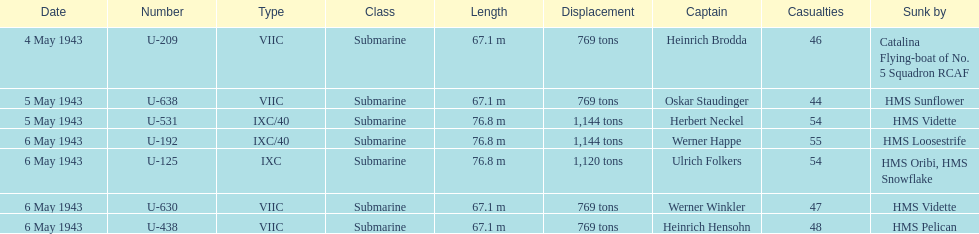How many more casualties occurred on may 6 compared to may 4? 158. 